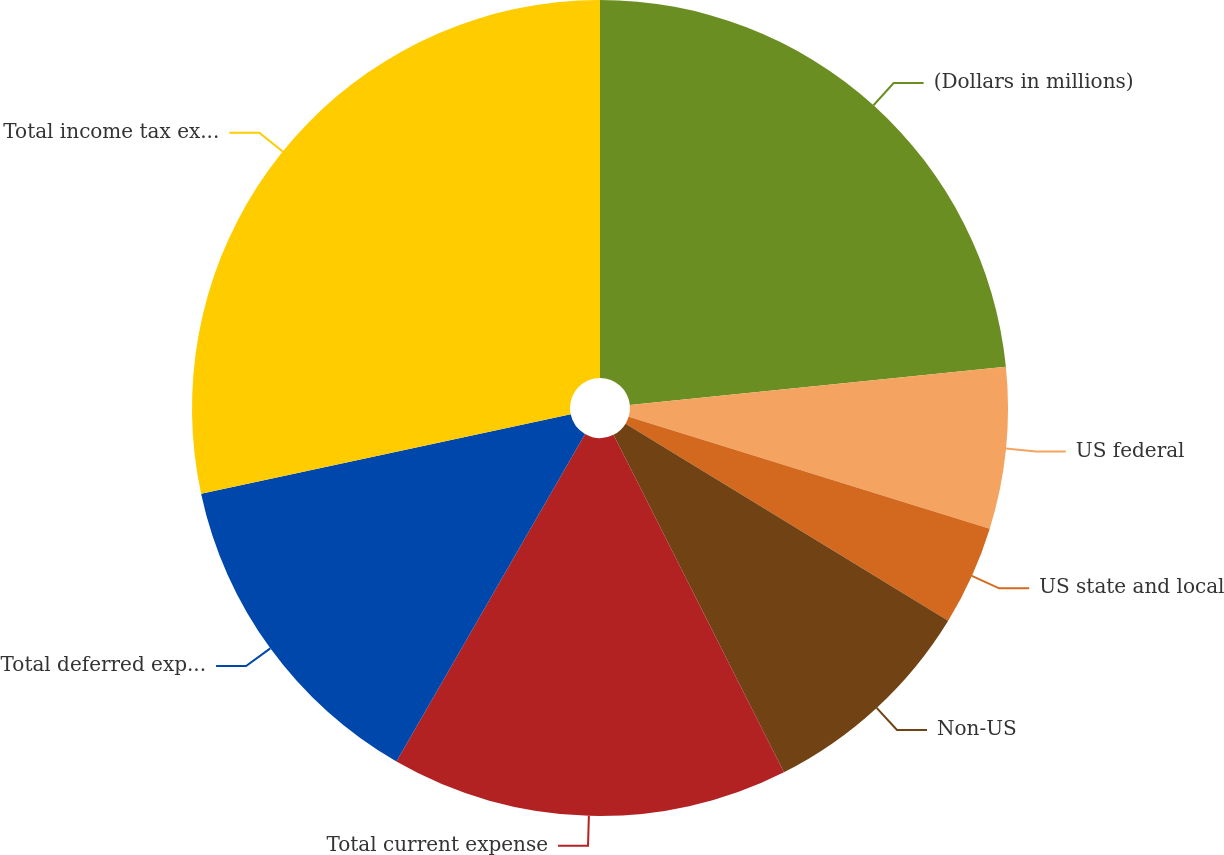Convert chart. <chart><loc_0><loc_0><loc_500><loc_500><pie_chart><fcel>(Dollars in millions)<fcel>US federal<fcel>US state and local<fcel>Non-US<fcel>Total current expense<fcel>Total deferred expense<fcel>Total income tax expense<nl><fcel>23.39%<fcel>6.39%<fcel>3.95%<fcel>8.83%<fcel>15.76%<fcel>13.32%<fcel>28.37%<nl></chart> 